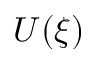Convert formula to latex. <formula><loc_0><loc_0><loc_500><loc_500>U ( \xi )</formula> 